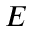Convert formula to latex. <formula><loc_0><loc_0><loc_500><loc_500>E</formula> 